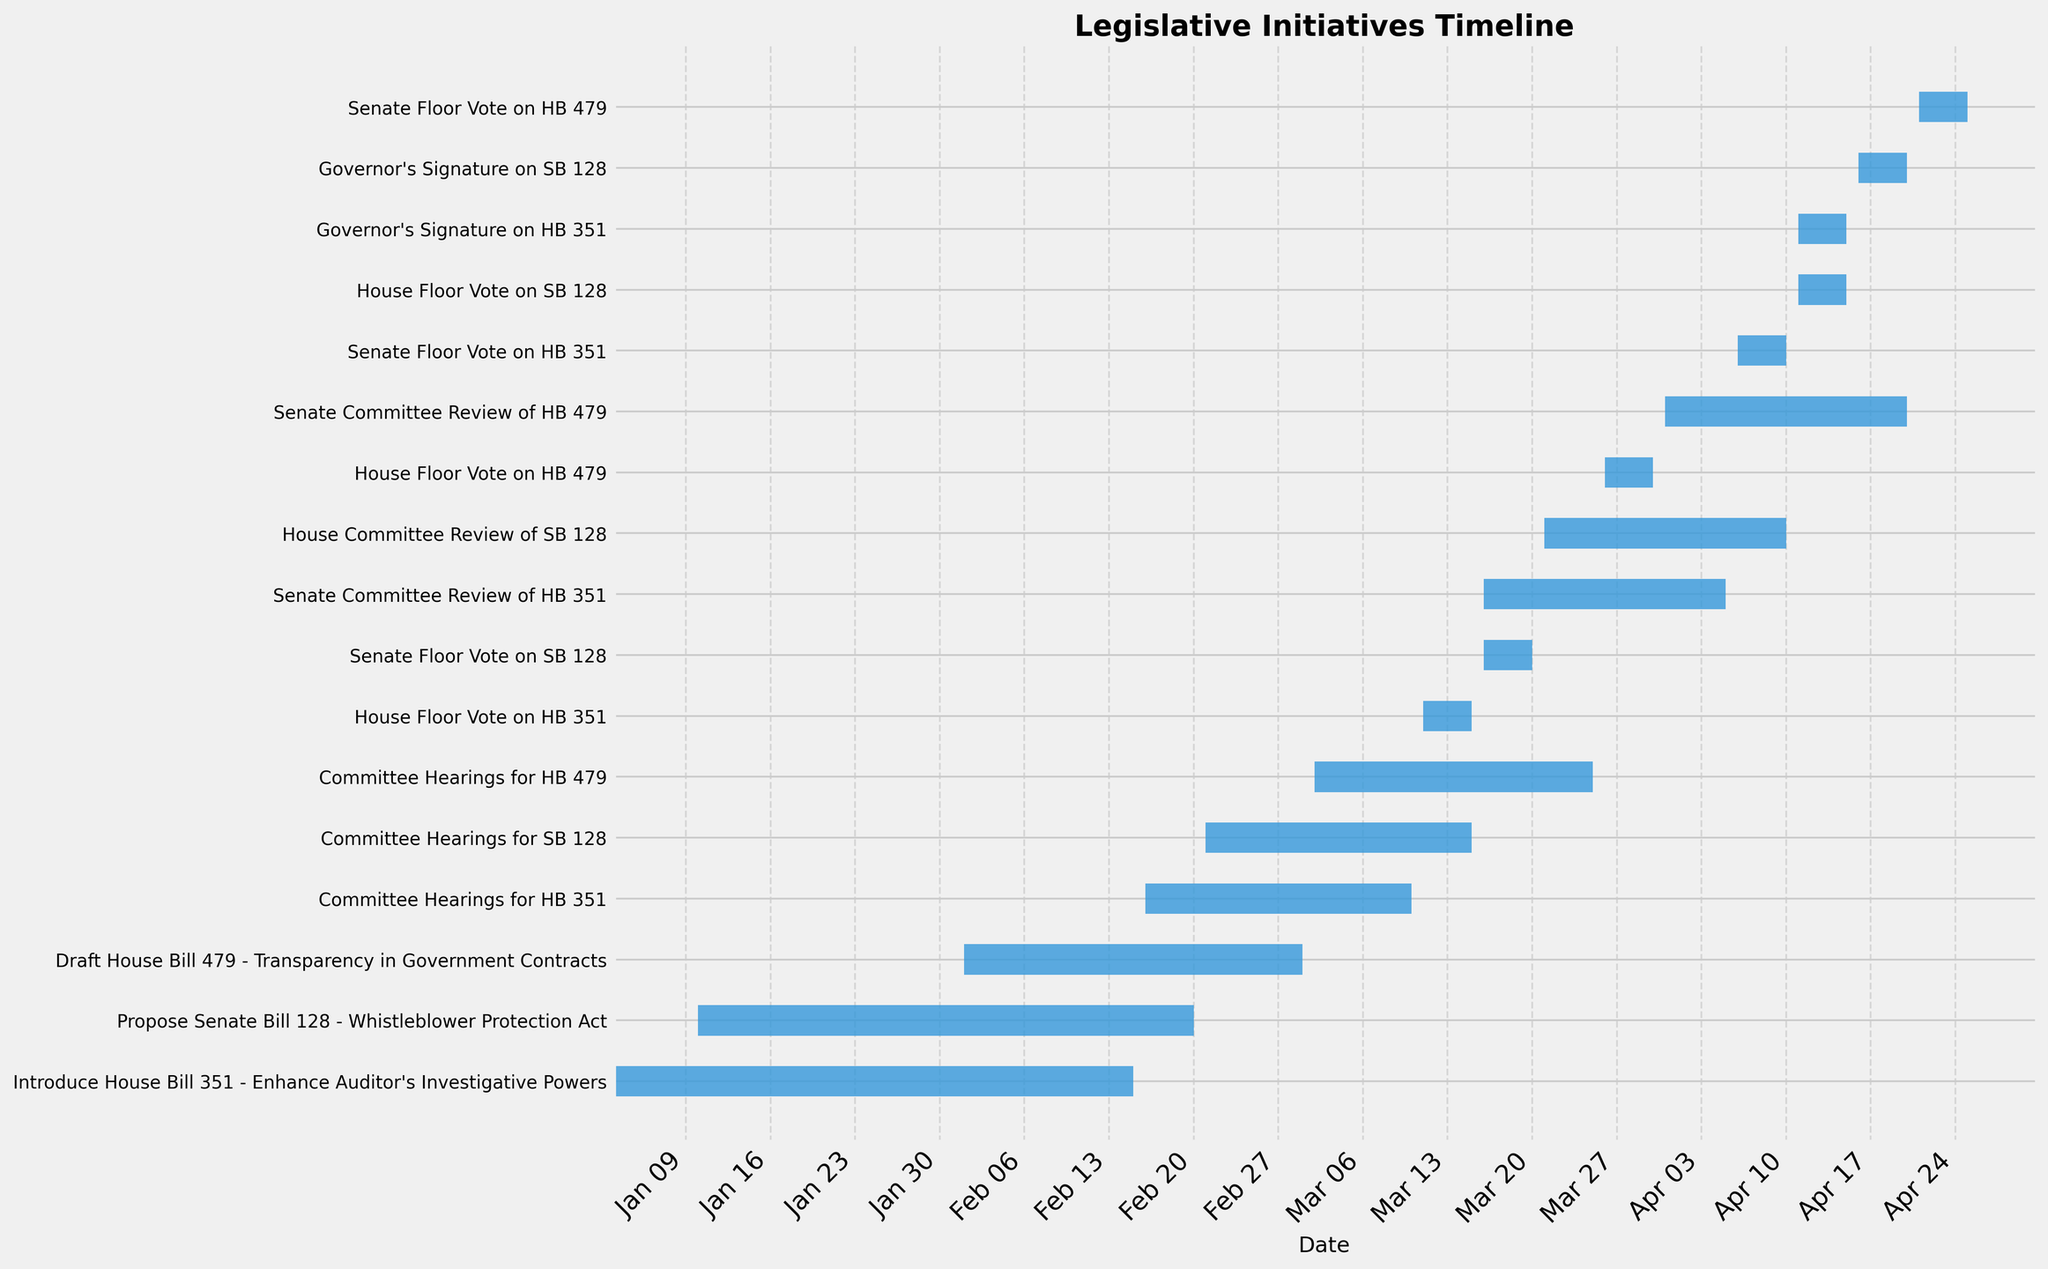What is the title of the Gantt Chart? The title of the Gantt Chart is usually found at the top of the chart. It provides a summary of what the chart is about.
Answer: Legislative Initiatives Timeline When was House Bill 351 introduced? To determine the start date of House Bill 351, locate the task named "Introduce House Bill 351 - Enhance Auditor's Investigative Powers" and read its start date.
Answer: January 3, 2023 What is the duration of the Committee Hearings for SB 128? Find the task labeled "Committee Hearings for SB 128" and calculate the number of days between its start and end dates.
Answer: 23 days Which bill took the longest time for the Committee Hearings, and what is its duration? Compare the duration of the Committee Hearings among HB 351, SB 128, and HB 479 by looking at the length of the bars and calculating the days between their start and end dates.
Answer: HB 479, 23 days Did the Senate Floor Vote for HB 351 and the House Floor Vote for SB 128 happen on the same day? To compare the dates, check the end date of the Senate Floor Vote for HB 351 and the start date of the House Floor Vote for SB 128.
Answer: Yes Which bill required the Governor's signature last, and what were the exact dates? Look at the task bars labeled with the Governor’s Signature for each bill and note the one with the most recent dates.
Answer: SB 128, April 16 to April 20, 2023 How many days were spent on House Committee Review of SB 128? Locate the task "House Committee Review of SB 128" and calculate the number of days between its start and end dates.
Answer: 21 days What legislative tasks were completed in March 2023? Identify all the tasks that have end dates within March 2023 by examining the timeline of each task.
Answer: Committee Hearings for HB 351, House Floor Vote on HB 351, Draft House Bill 479, Committee Hearings for HB 479, Senate Floor Vote on SB 128 Which bill had its Senate Committee Review completed first, and when did it start and end? Compare the Senate Committee Review tasks for all bills and identify which one concluded the earliest, noting its start and end dates.
Answer: HB 351, March 16 to April 5, 2023 What's the average duration of the legislative tasks related to HB 351? Calculate the duration of each task related to HB 351 and find their average. Tasks: Introduce HB 351, Committee Hearings, House Floor Vote, Senate Committee Review, Senate Floor Vote, Governor's Signature.
Answer: 12.5 days 